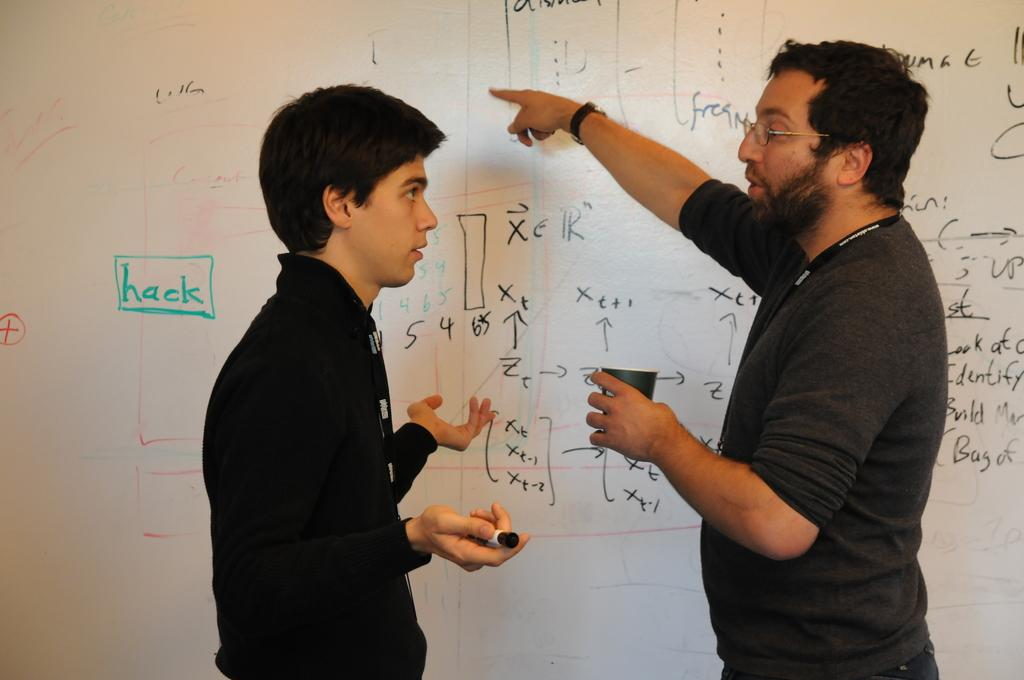Provide a one-sentence caption for the provided image. Two men in front of a white board with "hack" written in green. 